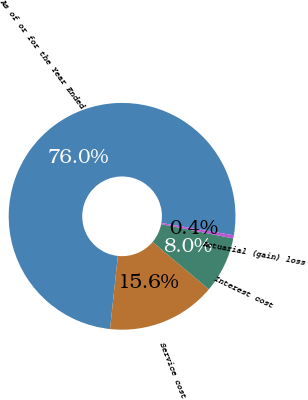Convert chart to OTSL. <chart><loc_0><loc_0><loc_500><loc_500><pie_chart><fcel>As of or for the Year Ended<fcel>Service cost<fcel>Interest cost<fcel>Actuarial (gain) loss<nl><fcel>75.98%<fcel>15.56%<fcel>8.01%<fcel>0.45%<nl></chart> 